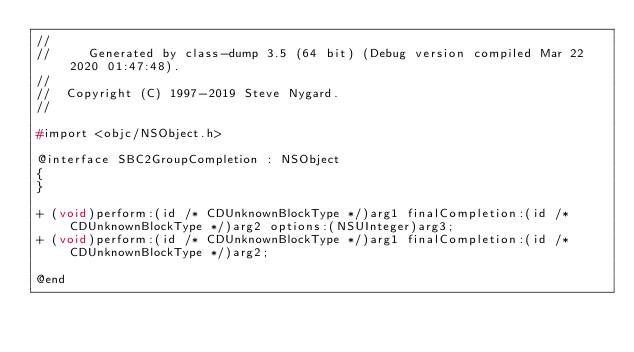<code> <loc_0><loc_0><loc_500><loc_500><_C_>//
//     Generated by class-dump 3.5 (64 bit) (Debug version compiled Mar 22 2020 01:47:48).
//
//  Copyright (C) 1997-2019 Steve Nygard.
//

#import <objc/NSObject.h>

@interface SBC2GroupCompletion : NSObject
{
}

+ (void)perform:(id /* CDUnknownBlockType */)arg1 finalCompletion:(id /* CDUnknownBlockType */)arg2 options:(NSUInteger)arg3;
+ (void)perform:(id /* CDUnknownBlockType */)arg1 finalCompletion:(id /* CDUnknownBlockType */)arg2;

@end

</code> 